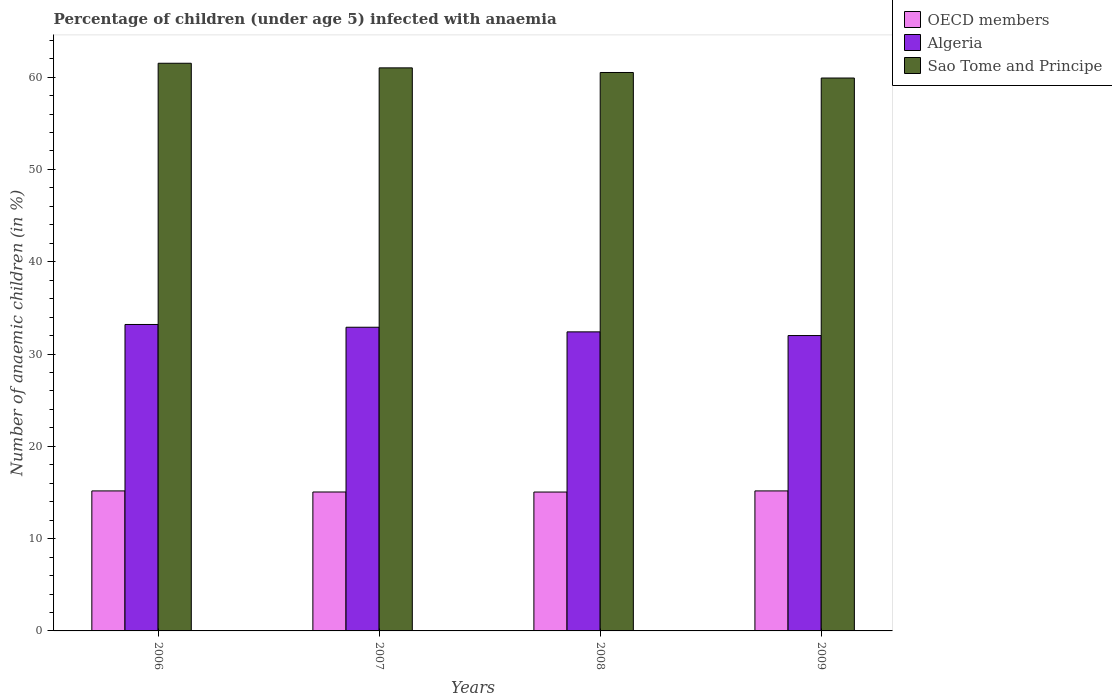How many different coloured bars are there?
Offer a very short reply. 3. Are the number of bars per tick equal to the number of legend labels?
Offer a terse response. Yes. In how many cases, is the number of bars for a given year not equal to the number of legend labels?
Make the answer very short. 0. What is the percentage of children infected with anaemia in in Sao Tome and Principe in 2007?
Give a very brief answer. 61. Across all years, what is the maximum percentage of children infected with anaemia in in Algeria?
Give a very brief answer. 33.2. Across all years, what is the minimum percentage of children infected with anaemia in in Sao Tome and Principe?
Your answer should be very brief. 59.9. In which year was the percentage of children infected with anaemia in in OECD members minimum?
Offer a very short reply. 2008. What is the total percentage of children infected with anaemia in in Algeria in the graph?
Ensure brevity in your answer.  130.5. What is the difference between the percentage of children infected with anaemia in in OECD members in 2009 and the percentage of children infected with anaemia in in Algeria in 2006?
Your response must be concise. -18.03. What is the average percentage of children infected with anaemia in in OECD members per year?
Provide a succinct answer. 15.11. In the year 2006, what is the difference between the percentage of children infected with anaemia in in Algeria and percentage of children infected with anaemia in in OECD members?
Ensure brevity in your answer.  18.03. What is the ratio of the percentage of children infected with anaemia in in OECD members in 2007 to that in 2008?
Your response must be concise. 1. What is the difference between the highest and the second highest percentage of children infected with anaemia in in Algeria?
Provide a succinct answer. 0.3. What is the difference between the highest and the lowest percentage of children infected with anaemia in in OECD members?
Offer a very short reply. 0.12. Is the sum of the percentage of children infected with anaemia in in OECD members in 2007 and 2008 greater than the maximum percentage of children infected with anaemia in in Sao Tome and Principe across all years?
Your answer should be compact. No. What does the 3rd bar from the left in 2007 represents?
Provide a short and direct response. Sao Tome and Principe. What does the 2nd bar from the right in 2008 represents?
Keep it short and to the point. Algeria. Is it the case that in every year, the sum of the percentage of children infected with anaemia in in Sao Tome and Principe and percentage of children infected with anaemia in in OECD members is greater than the percentage of children infected with anaemia in in Algeria?
Provide a succinct answer. Yes. How many bars are there?
Your answer should be compact. 12. Are all the bars in the graph horizontal?
Keep it short and to the point. No. Are the values on the major ticks of Y-axis written in scientific E-notation?
Ensure brevity in your answer.  No. Does the graph contain any zero values?
Your answer should be compact. No. What is the title of the graph?
Offer a terse response. Percentage of children (under age 5) infected with anaemia. Does "Euro area" appear as one of the legend labels in the graph?
Ensure brevity in your answer.  No. What is the label or title of the Y-axis?
Ensure brevity in your answer.  Number of anaemic children (in %). What is the Number of anaemic children (in %) in OECD members in 2006?
Offer a terse response. 15.17. What is the Number of anaemic children (in %) of Algeria in 2006?
Ensure brevity in your answer.  33.2. What is the Number of anaemic children (in %) of Sao Tome and Principe in 2006?
Your answer should be very brief. 61.5. What is the Number of anaemic children (in %) of OECD members in 2007?
Provide a succinct answer. 15.05. What is the Number of anaemic children (in %) in Algeria in 2007?
Provide a succinct answer. 32.9. What is the Number of anaemic children (in %) of OECD members in 2008?
Your answer should be very brief. 15.05. What is the Number of anaemic children (in %) in Algeria in 2008?
Give a very brief answer. 32.4. What is the Number of anaemic children (in %) in Sao Tome and Principe in 2008?
Keep it short and to the point. 60.5. What is the Number of anaemic children (in %) of OECD members in 2009?
Offer a very short reply. 15.17. What is the Number of anaemic children (in %) of Sao Tome and Principe in 2009?
Your answer should be very brief. 59.9. Across all years, what is the maximum Number of anaemic children (in %) of OECD members?
Ensure brevity in your answer.  15.17. Across all years, what is the maximum Number of anaemic children (in %) of Algeria?
Your answer should be compact. 33.2. Across all years, what is the maximum Number of anaemic children (in %) of Sao Tome and Principe?
Give a very brief answer. 61.5. Across all years, what is the minimum Number of anaemic children (in %) in OECD members?
Offer a very short reply. 15.05. Across all years, what is the minimum Number of anaemic children (in %) in Sao Tome and Principe?
Provide a short and direct response. 59.9. What is the total Number of anaemic children (in %) of OECD members in the graph?
Your answer should be compact. 60.44. What is the total Number of anaemic children (in %) in Algeria in the graph?
Your response must be concise. 130.5. What is the total Number of anaemic children (in %) of Sao Tome and Principe in the graph?
Your answer should be compact. 242.9. What is the difference between the Number of anaemic children (in %) of OECD members in 2006 and that in 2007?
Keep it short and to the point. 0.12. What is the difference between the Number of anaemic children (in %) of Sao Tome and Principe in 2006 and that in 2007?
Make the answer very short. 0.5. What is the difference between the Number of anaemic children (in %) in OECD members in 2006 and that in 2008?
Give a very brief answer. 0.12. What is the difference between the Number of anaemic children (in %) of Algeria in 2006 and that in 2008?
Your answer should be very brief. 0.8. What is the difference between the Number of anaemic children (in %) in Sao Tome and Principe in 2006 and that in 2009?
Offer a very short reply. 1.6. What is the difference between the Number of anaemic children (in %) in OECD members in 2007 and that in 2008?
Give a very brief answer. 0. What is the difference between the Number of anaemic children (in %) of Algeria in 2007 and that in 2008?
Ensure brevity in your answer.  0.5. What is the difference between the Number of anaemic children (in %) of Sao Tome and Principe in 2007 and that in 2008?
Offer a terse response. 0.5. What is the difference between the Number of anaemic children (in %) in OECD members in 2007 and that in 2009?
Your answer should be compact. -0.12. What is the difference between the Number of anaemic children (in %) in Algeria in 2007 and that in 2009?
Provide a short and direct response. 0.9. What is the difference between the Number of anaemic children (in %) in Sao Tome and Principe in 2007 and that in 2009?
Your answer should be very brief. 1.1. What is the difference between the Number of anaemic children (in %) of OECD members in 2008 and that in 2009?
Keep it short and to the point. -0.12. What is the difference between the Number of anaemic children (in %) in OECD members in 2006 and the Number of anaemic children (in %) in Algeria in 2007?
Give a very brief answer. -17.73. What is the difference between the Number of anaemic children (in %) of OECD members in 2006 and the Number of anaemic children (in %) of Sao Tome and Principe in 2007?
Your answer should be very brief. -45.83. What is the difference between the Number of anaemic children (in %) of Algeria in 2006 and the Number of anaemic children (in %) of Sao Tome and Principe in 2007?
Your response must be concise. -27.8. What is the difference between the Number of anaemic children (in %) in OECD members in 2006 and the Number of anaemic children (in %) in Algeria in 2008?
Ensure brevity in your answer.  -17.23. What is the difference between the Number of anaemic children (in %) in OECD members in 2006 and the Number of anaemic children (in %) in Sao Tome and Principe in 2008?
Give a very brief answer. -45.33. What is the difference between the Number of anaemic children (in %) of Algeria in 2006 and the Number of anaemic children (in %) of Sao Tome and Principe in 2008?
Give a very brief answer. -27.3. What is the difference between the Number of anaemic children (in %) in OECD members in 2006 and the Number of anaemic children (in %) in Algeria in 2009?
Provide a succinct answer. -16.83. What is the difference between the Number of anaemic children (in %) in OECD members in 2006 and the Number of anaemic children (in %) in Sao Tome and Principe in 2009?
Provide a succinct answer. -44.73. What is the difference between the Number of anaemic children (in %) in Algeria in 2006 and the Number of anaemic children (in %) in Sao Tome and Principe in 2009?
Keep it short and to the point. -26.7. What is the difference between the Number of anaemic children (in %) in OECD members in 2007 and the Number of anaemic children (in %) in Algeria in 2008?
Give a very brief answer. -17.35. What is the difference between the Number of anaemic children (in %) in OECD members in 2007 and the Number of anaemic children (in %) in Sao Tome and Principe in 2008?
Give a very brief answer. -45.45. What is the difference between the Number of anaemic children (in %) in Algeria in 2007 and the Number of anaemic children (in %) in Sao Tome and Principe in 2008?
Provide a short and direct response. -27.6. What is the difference between the Number of anaemic children (in %) of OECD members in 2007 and the Number of anaemic children (in %) of Algeria in 2009?
Ensure brevity in your answer.  -16.95. What is the difference between the Number of anaemic children (in %) of OECD members in 2007 and the Number of anaemic children (in %) of Sao Tome and Principe in 2009?
Ensure brevity in your answer.  -44.85. What is the difference between the Number of anaemic children (in %) of OECD members in 2008 and the Number of anaemic children (in %) of Algeria in 2009?
Your answer should be very brief. -16.95. What is the difference between the Number of anaemic children (in %) of OECD members in 2008 and the Number of anaemic children (in %) of Sao Tome and Principe in 2009?
Make the answer very short. -44.85. What is the difference between the Number of anaemic children (in %) in Algeria in 2008 and the Number of anaemic children (in %) in Sao Tome and Principe in 2009?
Ensure brevity in your answer.  -27.5. What is the average Number of anaemic children (in %) in OECD members per year?
Make the answer very short. 15.11. What is the average Number of anaemic children (in %) of Algeria per year?
Your answer should be compact. 32.62. What is the average Number of anaemic children (in %) in Sao Tome and Principe per year?
Make the answer very short. 60.73. In the year 2006, what is the difference between the Number of anaemic children (in %) in OECD members and Number of anaemic children (in %) in Algeria?
Ensure brevity in your answer.  -18.03. In the year 2006, what is the difference between the Number of anaemic children (in %) of OECD members and Number of anaemic children (in %) of Sao Tome and Principe?
Offer a very short reply. -46.33. In the year 2006, what is the difference between the Number of anaemic children (in %) of Algeria and Number of anaemic children (in %) of Sao Tome and Principe?
Your answer should be very brief. -28.3. In the year 2007, what is the difference between the Number of anaemic children (in %) in OECD members and Number of anaemic children (in %) in Algeria?
Provide a short and direct response. -17.85. In the year 2007, what is the difference between the Number of anaemic children (in %) in OECD members and Number of anaemic children (in %) in Sao Tome and Principe?
Offer a terse response. -45.95. In the year 2007, what is the difference between the Number of anaemic children (in %) in Algeria and Number of anaemic children (in %) in Sao Tome and Principe?
Keep it short and to the point. -28.1. In the year 2008, what is the difference between the Number of anaemic children (in %) of OECD members and Number of anaemic children (in %) of Algeria?
Provide a succinct answer. -17.35. In the year 2008, what is the difference between the Number of anaemic children (in %) in OECD members and Number of anaemic children (in %) in Sao Tome and Principe?
Offer a terse response. -45.45. In the year 2008, what is the difference between the Number of anaemic children (in %) in Algeria and Number of anaemic children (in %) in Sao Tome and Principe?
Your answer should be compact. -28.1. In the year 2009, what is the difference between the Number of anaemic children (in %) in OECD members and Number of anaemic children (in %) in Algeria?
Provide a short and direct response. -16.83. In the year 2009, what is the difference between the Number of anaemic children (in %) in OECD members and Number of anaemic children (in %) in Sao Tome and Principe?
Provide a short and direct response. -44.73. In the year 2009, what is the difference between the Number of anaemic children (in %) in Algeria and Number of anaemic children (in %) in Sao Tome and Principe?
Make the answer very short. -27.9. What is the ratio of the Number of anaemic children (in %) of Algeria in 2006 to that in 2007?
Offer a very short reply. 1.01. What is the ratio of the Number of anaemic children (in %) in Sao Tome and Principe in 2006 to that in 2007?
Your response must be concise. 1.01. What is the ratio of the Number of anaemic children (in %) in Algeria in 2006 to that in 2008?
Ensure brevity in your answer.  1.02. What is the ratio of the Number of anaemic children (in %) of Sao Tome and Principe in 2006 to that in 2008?
Give a very brief answer. 1.02. What is the ratio of the Number of anaemic children (in %) in Algeria in 2006 to that in 2009?
Make the answer very short. 1.04. What is the ratio of the Number of anaemic children (in %) of Sao Tome and Principe in 2006 to that in 2009?
Offer a terse response. 1.03. What is the ratio of the Number of anaemic children (in %) of Algeria in 2007 to that in 2008?
Ensure brevity in your answer.  1.02. What is the ratio of the Number of anaemic children (in %) in Sao Tome and Principe in 2007 to that in 2008?
Provide a succinct answer. 1.01. What is the ratio of the Number of anaemic children (in %) of Algeria in 2007 to that in 2009?
Offer a very short reply. 1.03. What is the ratio of the Number of anaemic children (in %) of Sao Tome and Principe in 2007 to that in 2009?
Offer a terse response. 1.02. What is the ratio of the Number of anaemic children (in %) in OECD members in 2008 to that in 2009?
Ensure brevity in your answer.  0.99. What is the ratio of the Number of anaemic children (in %) of Algeria in 2008 to that in 2009?
Give a very brief answer. 1.01. What is the difference between the highest and the second highest Number of anaemic children (in %) in OECD members?
Keep it short and to the point. 0. What is the difference between the highest and the second highest Number of anaemic children (in %) in Algeria?
Your response must be concise. 0.3. What is the difference between the highest and the second highest Number of anaemic children (in %) of Sao Tome and Principe?
Provide a succinct answer. 0.5. What is the difference between the highest and the lowest Number of anaemic children (in %) of OECD members?
Ensure brevity in your answer.  0.12. What is the difference between the highest and the lowest Number of anaemic children (in %) in Algeria?
Your answer should be very brief. 1.2. What is the difference between the highest and the lowest Number of anaemic children (in %) in Sao Tome and Principe?
Provide a short and direct response. 1.6. 